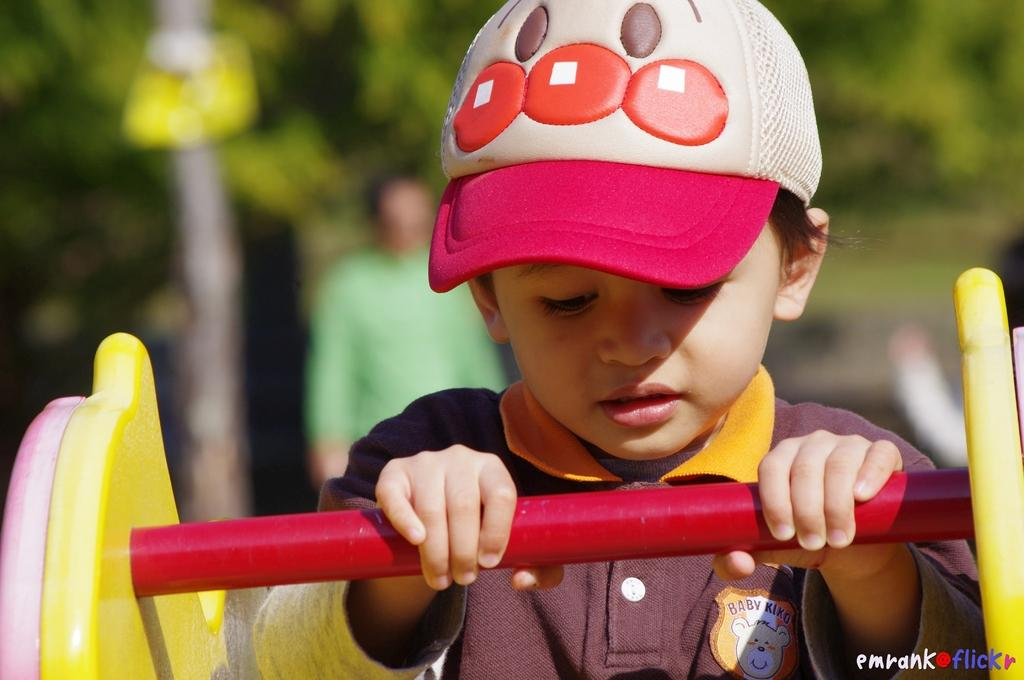What is the main subject of the image? The main subject of the image is a kid. What is the kid wearing? The kid is wearing a cap. What is the kid holding in the image? The kid is holding a rod. Can you describe the background of the image? The background of the image is blurred, but trees and a man are visible. What type of wire is the kid using to catch the ducks in the image? There are no ducks or wire present in the image. What agreement did the man and the kid reach in the image? There is no indication of an agreement between the man and the kid in the image. 